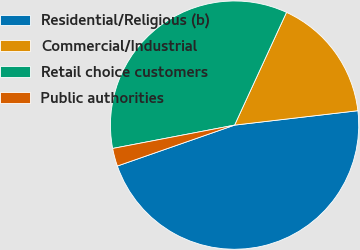<chart> <loc_0><loc_0><loc_500><loc_500><pie_chart><fcel>Residential/Religious (b)<fcel>Commercial/Industrial<fcel>Retail choice customers<fcel>Public authorities<nl><fcel>46.51%<fcel>16.28%<fcel>34.88%<fcel>2.33%<nl></chart> 